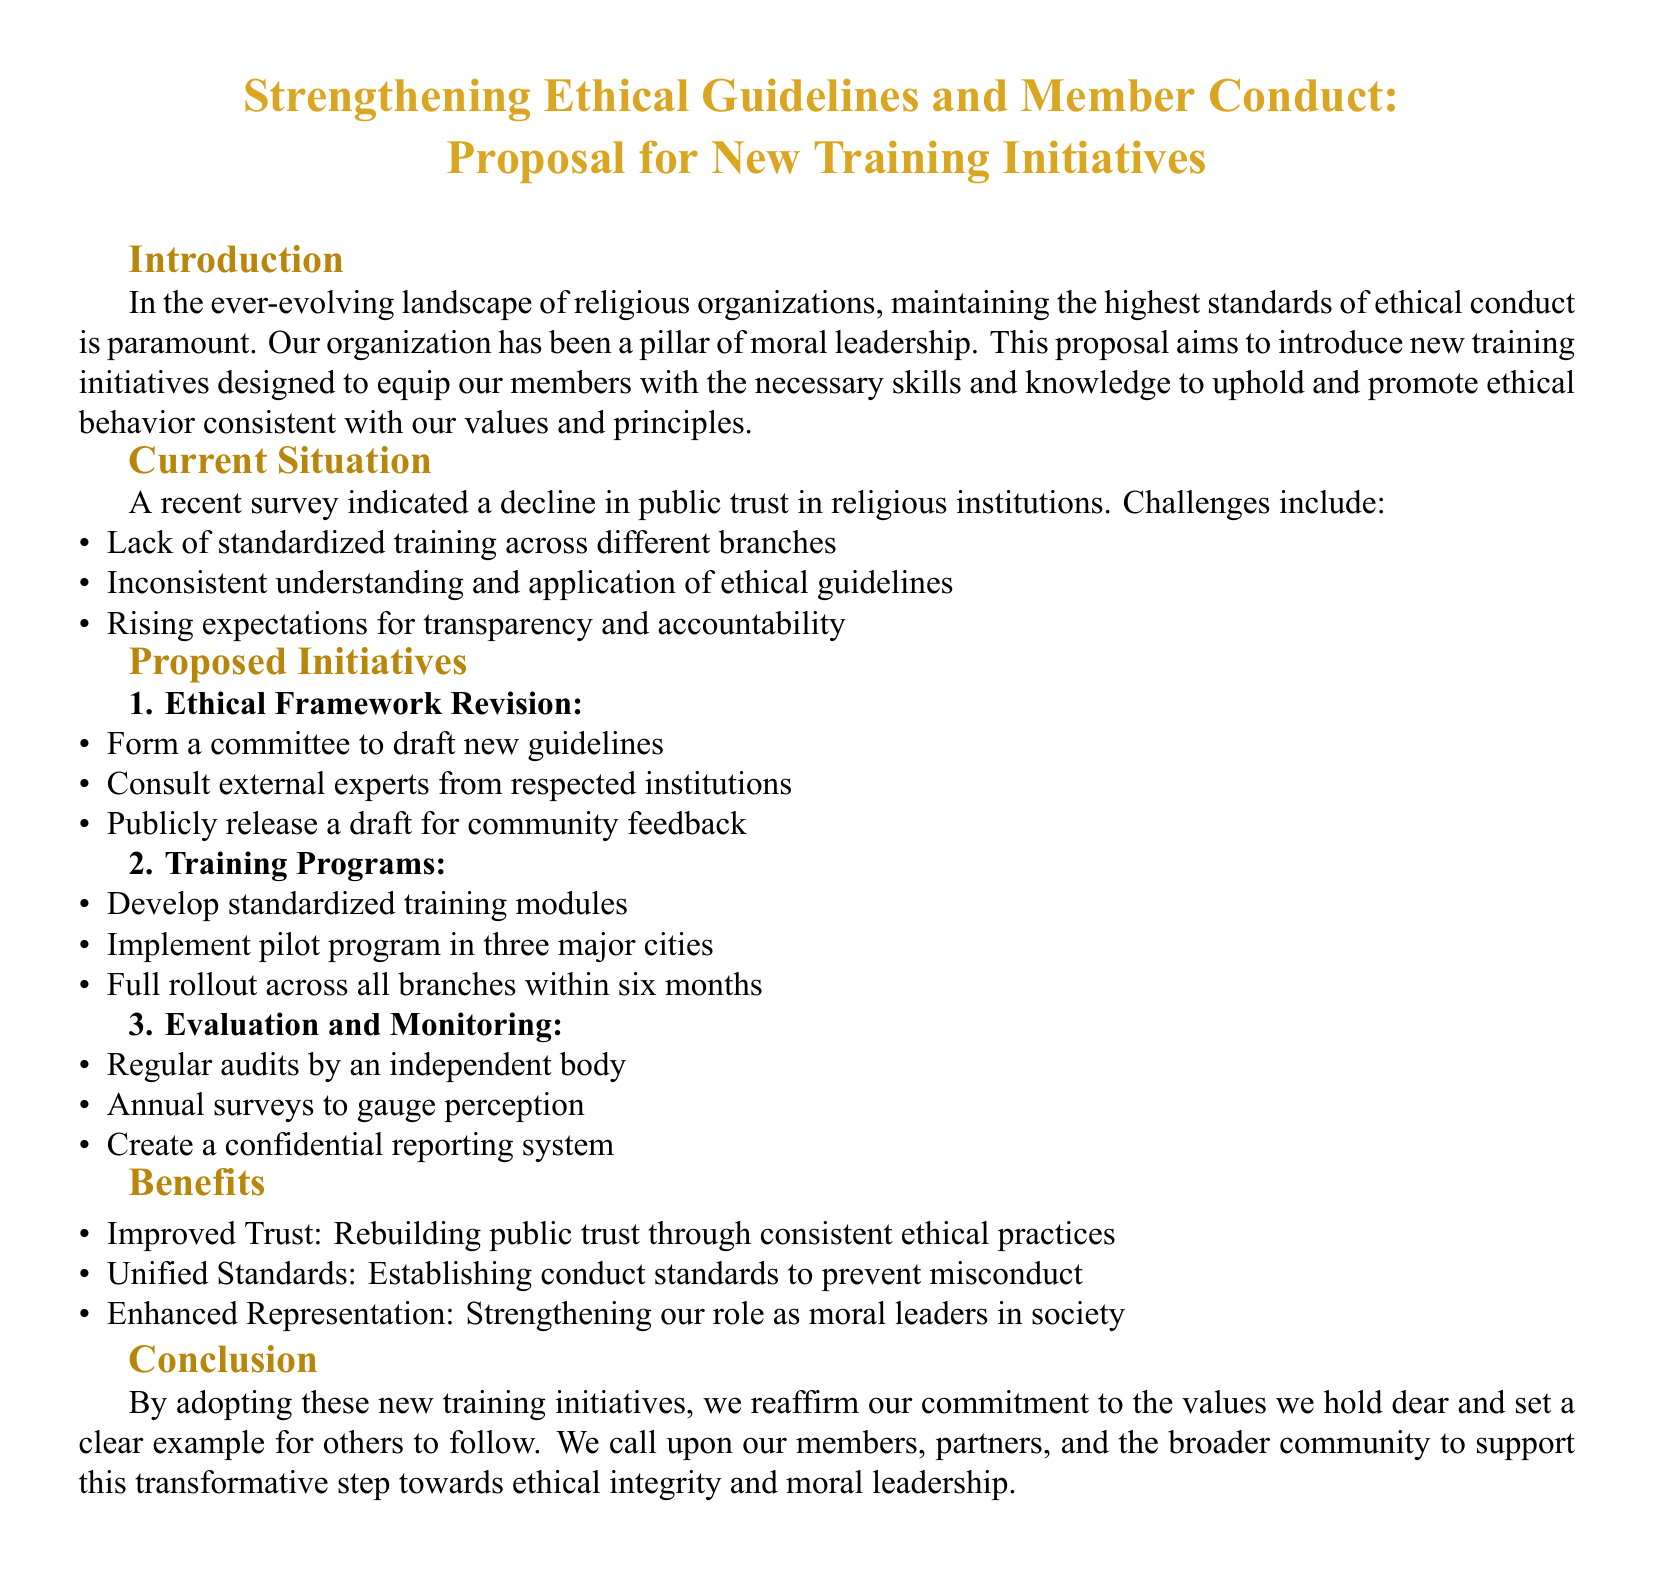what is the primary goal of the proposal? The primary goal is to introduce new training initiatives designed to equip our members with the necessary skills and knowledge to uphold and promote ethical behavior.
Answer: new training initiatives what is indicated by the recent survey? The recent survey indicated a decline in public trust in religious institutions.
Answer: decline in public trust how many proposed training programs are mentioned? Three training programs are included in the proposed initiatives: Ethical Framework Revision, Training Programs, and Evaluation and Monitoring.
Answer: three what is one of the benefits of the proposed initiatives? One benefit is Improved Trust through consistent ethical practices.
Answer: Improved Trust what is the timeframe for the full rollout of training modules? The full rollout is planned within six months after the pilot program.
Answer: six months who will conduct regular audits according to the proposal? Regular audits will be conducted by an independent body.
Answer: independent body what type of feedback will be sought for the new guidelines? The proposal states that a draft will be publicly released for community feedback.
Answer: community feedback what is the aim of forming a committee? The committee aims to draft new guidelines for ethical conduct.
Answer: draft new guidelines what is one method proposed for evaluating member perception? The proposal suggests conducting annual surveys to gauge perception.
Answer: annual surveys 